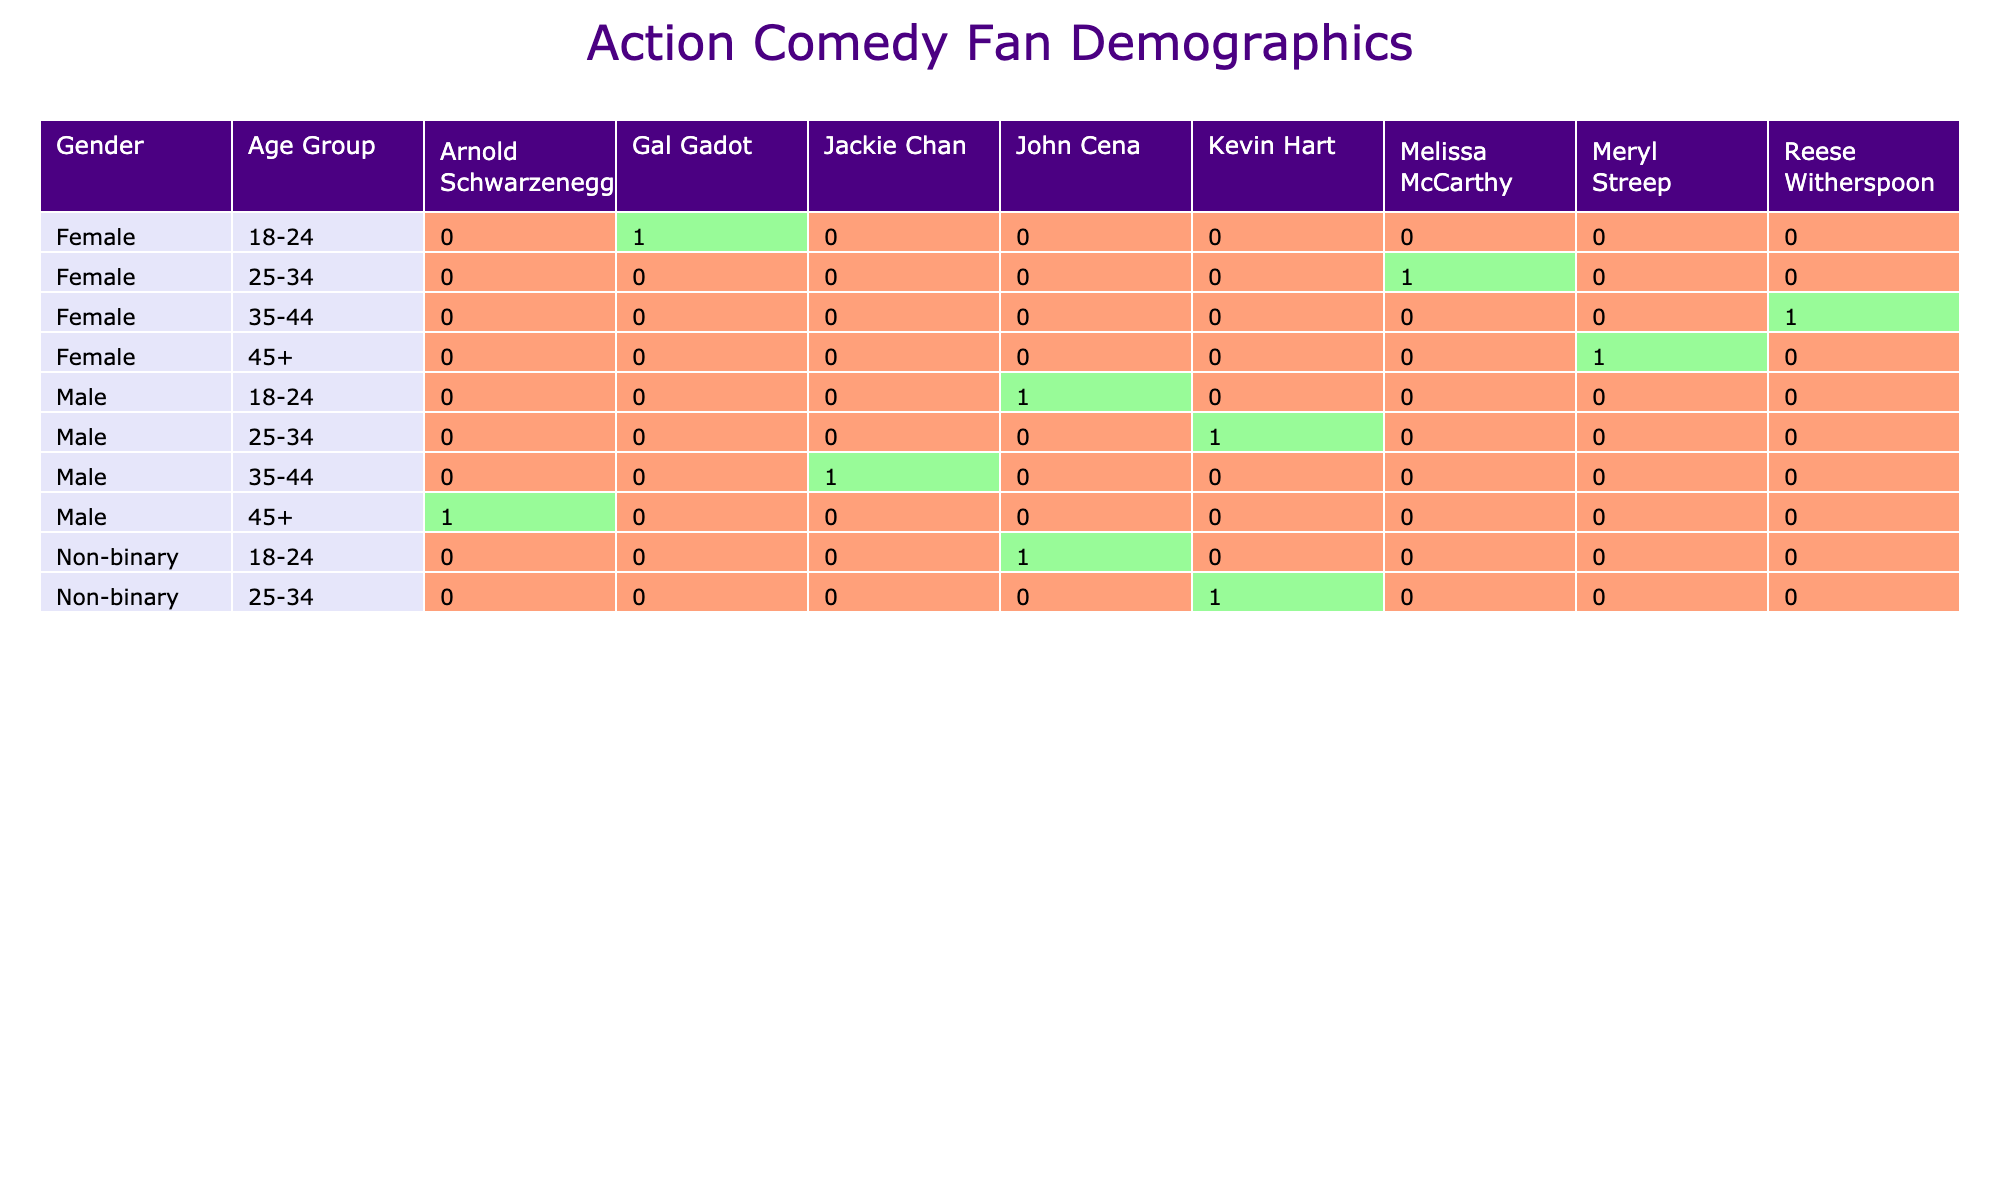What is the total number of male action comedy fans in the 18-24 age group? In the table, we focus on the rows where the gender is "Male" and the age group is "18-24." There is 1 entry that fits this criterion, which states "John Cena" with a "High" interest level. Thus, the total number of male fans in this group is 1.
Answer: 1 How many female fans have a high interest level in action comedies? To find the number of female fans with a high interest level, we review the rows where gender is "Female" and interest level is "High." There is 1 entry stating "Gal Gadot" under these criteria, so the total is 1.
Answer: 1 Which actor has the highest interest level among male fans aged 25-34? In the data for male fans aged 25-34, there is 1 entry for "Kevin Hart" with a "Medium" interest level. As this is the only actor listed for this age and gender, he is the highest, thus the answer is Kevin Hart.
Answer: Kevin Hart Are there any non-binary fans in the 25-34 age group with a low interest level? We look for rows where gender is "Non-binary," age group is "25-34," and interest level is "Low." In the data provided, there's no entry fitting this description. Thus, the answer is no.
Answer: No What is the average interest level of action comedy fans for the age group 35-44? For the age group "35-44," we have male and female entries: "Jackie Chan" (Low) and "Reese Witherspoon" (Low). Since both interest levels are "Low," we assign values (High=3, Medium=2, Low=1) and calculate the average. The sum is (1 + 1) = 2 for 2 fans, thus the average is 2/2 = 1.
Answer: 1 What percentage of the non-binary fans prefer John Cena? There are 2 non-binary entries in total: one for "John Cena" and one for "Kevin Hart." The number of non-binary fans that prefer John Cena is 1. To find the percentage, we calculate (1/2) * 100 = 50%.
Answer: 50% Is there a female fan who prefers John Cena? Examining the data for female fans, we check the entries, and there are no females listed under "Favorite Actor" as "John Cena." Therefore, the answer is no.
Answer: No How many total fans are there aged 45 and above? For the age group "45+", we have entries for "Arnold Schwarzenegger" (Male, Medium) and "Meryl Streep" (Female, Low). Thus, there are 2 fans in total aged 45 and above.
Answer: 2 